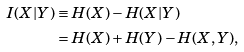<formula> <loc_0><loc_0><loc_500><loc_500>I ( X | Y ) & \equiv H ( X ) - H ( X | Y ) \\ & = H ( X ) + H ( Y ) - H ( X , Y ) ,</formula> 